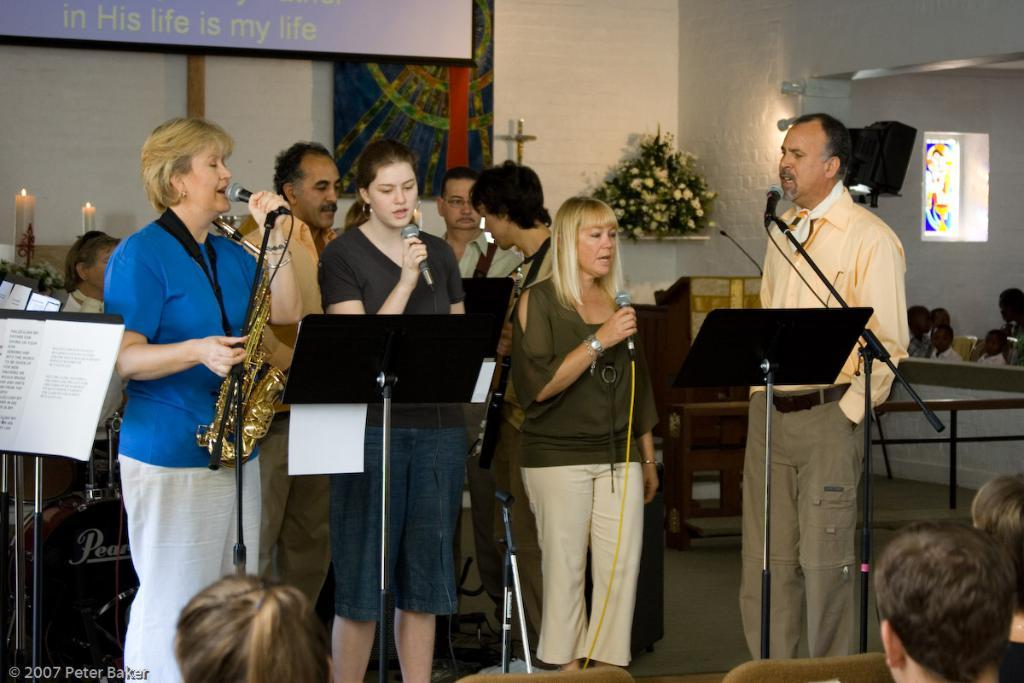What type of structure can be seen in the image? There is a wall in the image. What is hanging on the wall? There is a banner in the image. What objects are present that might provide light? There are candles in the image. What type of paper is visible in the image? There is a paper in the image. Can you describe the people in the image? There is a group of people in the image. What objects might be used for amplifying sound? There are microphones (mics) in the image. What type of decorative item can be seen in the image? There is a photo frame in the image. What type of plant life is visible in the image? There are flowers in the image. How many cats can be seen playing with ants on the farm in the image? There are no cats, ants, or farms present in the image. 